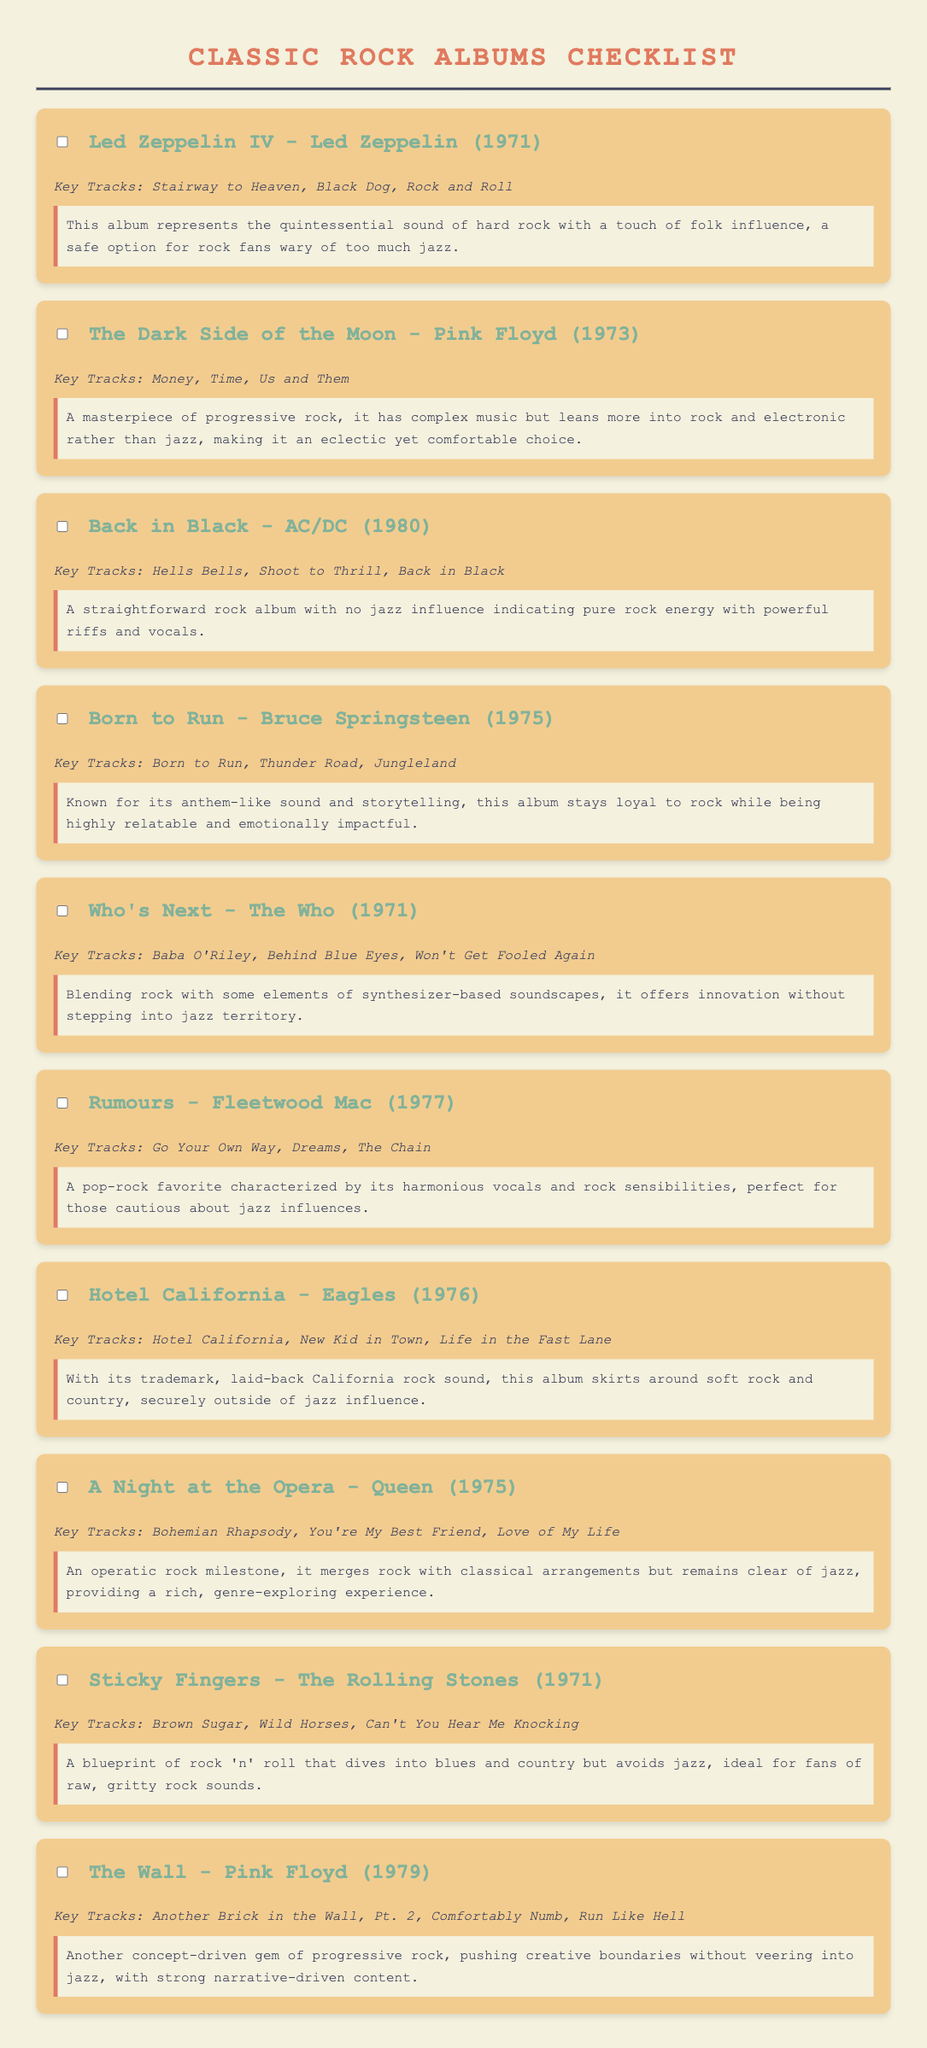What is the title of the first album listed? The title of the first album is found in the document under the first "album" section.
Answer: Led Zeppelin IV How many key tracks are listed for "The Wall"? The number of key tracks is shown in the details of "The Wall," specifically in its respective section.
Answer: Three Which artist created the album "Born to Run"? The artist for "Born to Run" is mentioned directly in the title of that album section.
Answer: Bruce Springsteen What year was "Sticky Fingers" released? The year of release is specified right after the album title in its section.
Answer: 1971 Which album's key track includes "Money"? The album with "Money" as a key track is identified in its section where key tracks are listed.
Answer: The Dark Side of the Moon What type of rock sound is associated with "Hotel California"? The type of sound is described in the notes section of the "Hotel California" album.
Answer: Laid-back California rock Which album is noted for blending rock with classical arrangements? This detail can be found in the notes section for the relevant album in the document.
Answer: A Night at the Opera What genre influence does "Back in Black" specifically avoid? The influence avoided by "Back in Black" is detailed in the notes section of that album.
Answer: Jazz How many albums were released in the 1970s? The total number of albums from the 1970s can be counted from the sections that list albums with corresponding years.
Answer: Five 